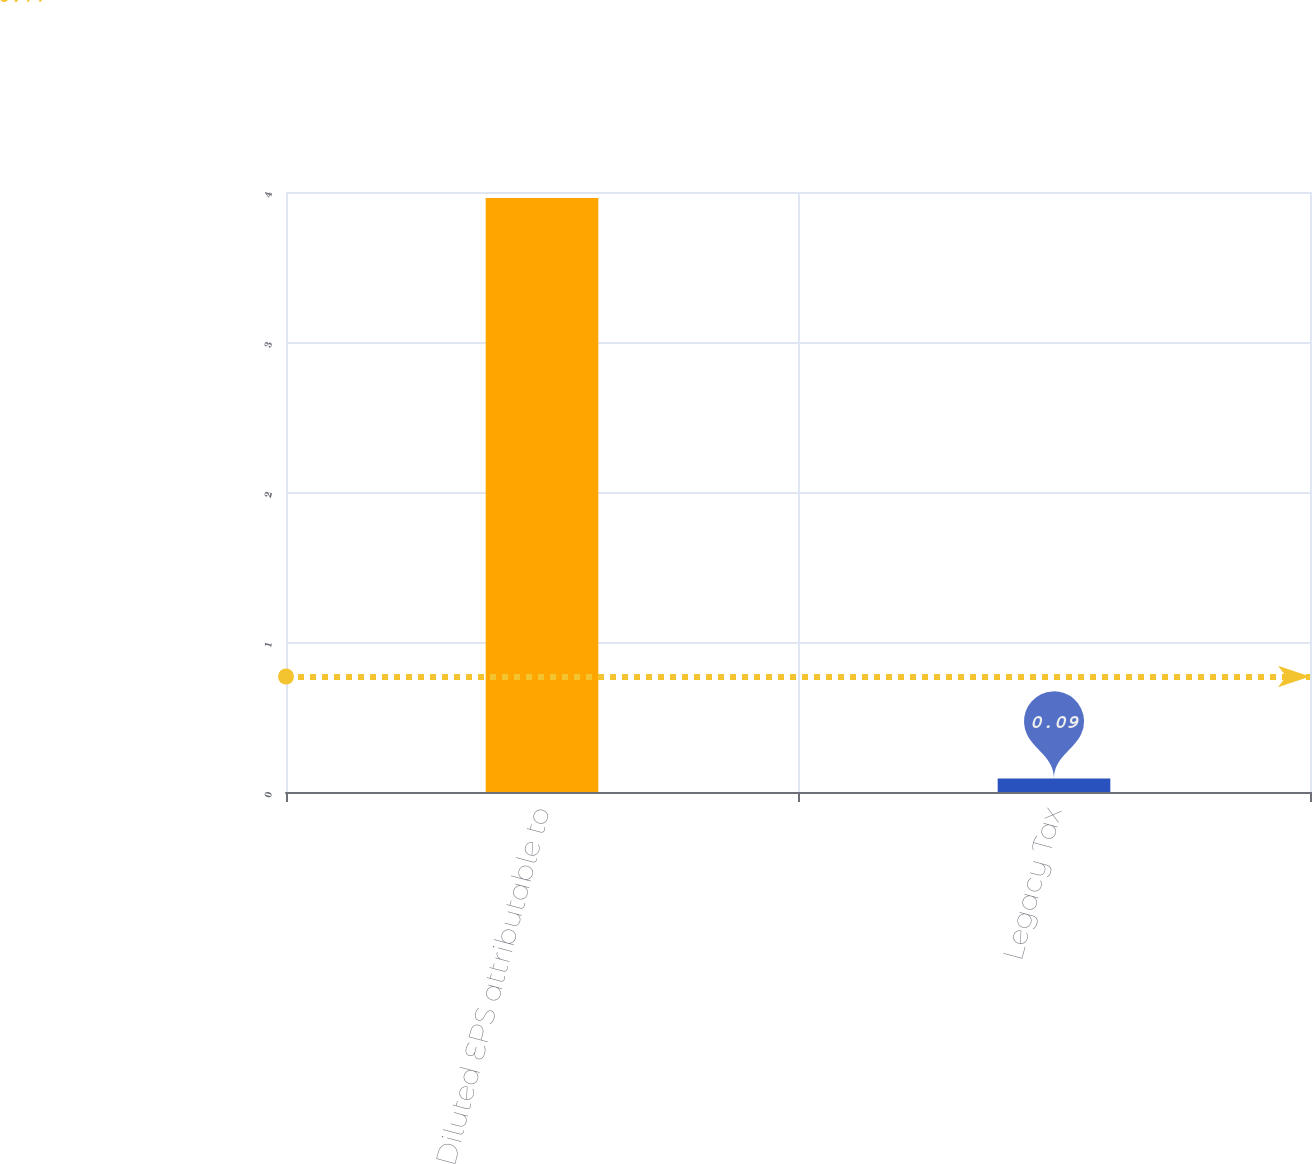Convert chart. <chart><loc_0><loc_0><loc_500><loc_500><bar_chart><fcel>Diluted EPS attributable to<fcel>Legacy Tax<nl><fcel>3.96<fcel>0.09<nl></chart> 